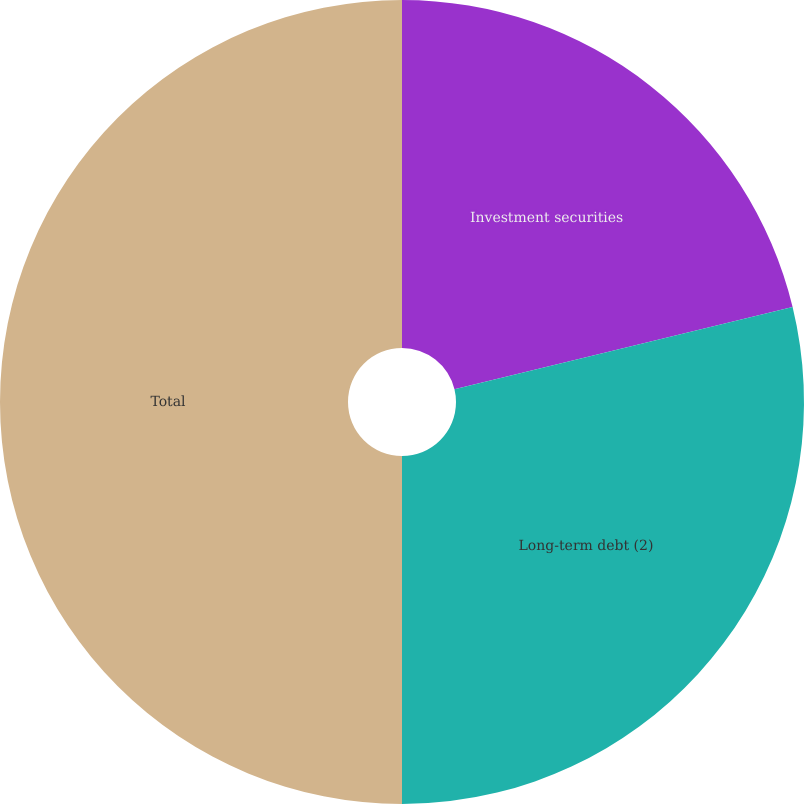Convert chart. <chart><loc_0><loc_0><loc_500><loc_500><pie_chart><fcel>Investment securities<fcel>Long-term debt (2)<fcel>Total<nl><fcel>21.2%<fcel>28.8%<fcel>50.0%<nl></chart> 